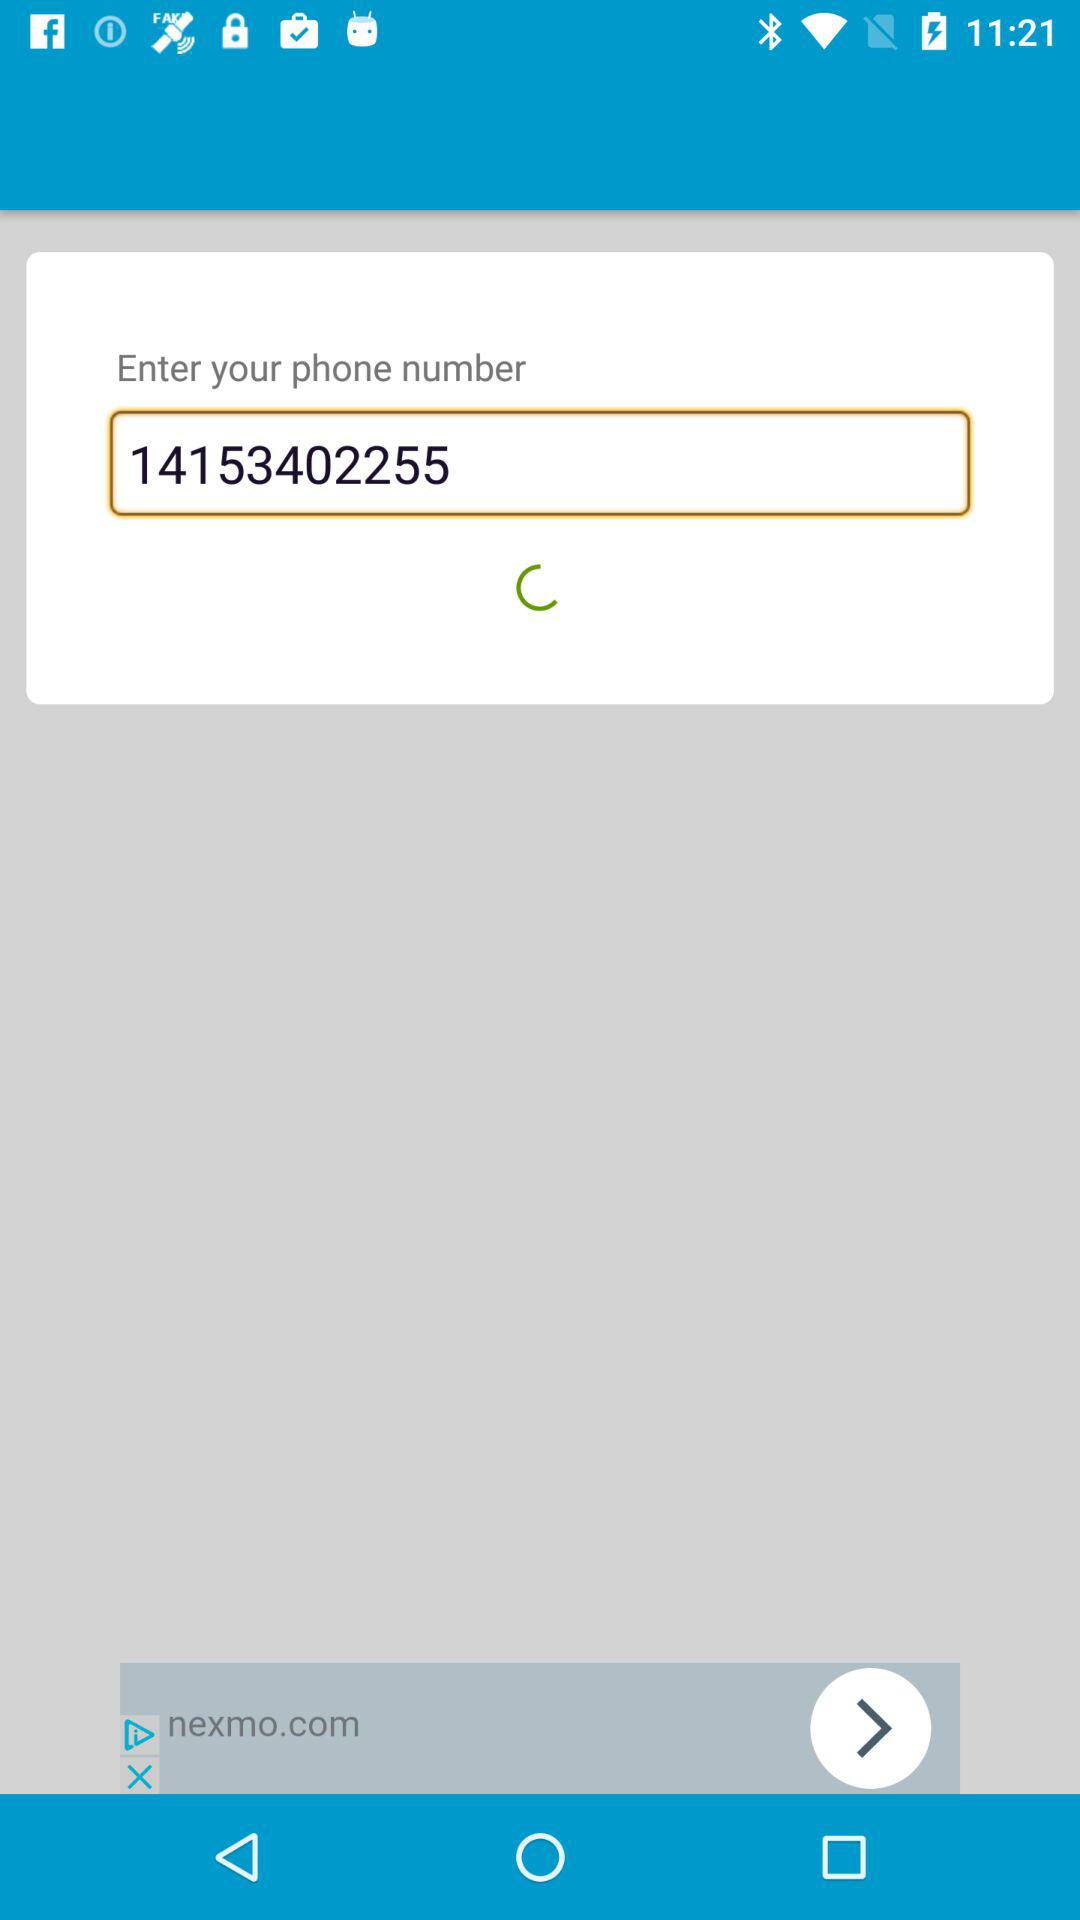What is the phone number? The phone number is 14153402255. 